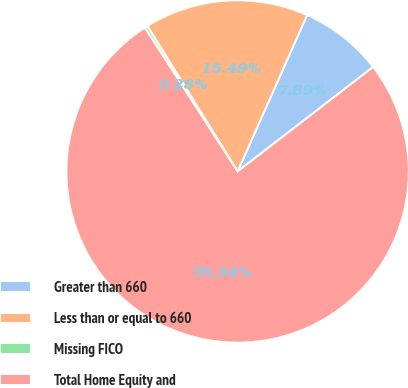Convert chart to OTSL. <chart><loc_0><loc_0><loc_500><loc_500><pie_chart><fcel>Greater than 660<fcel>Less than or equal to 660<fcel>Missing FICO<fcel>Total Home Equity and<nl><fcel>7.89%<fcel>15.49%<fcel>0.28%<fcel>76.33%<nl></chart> 